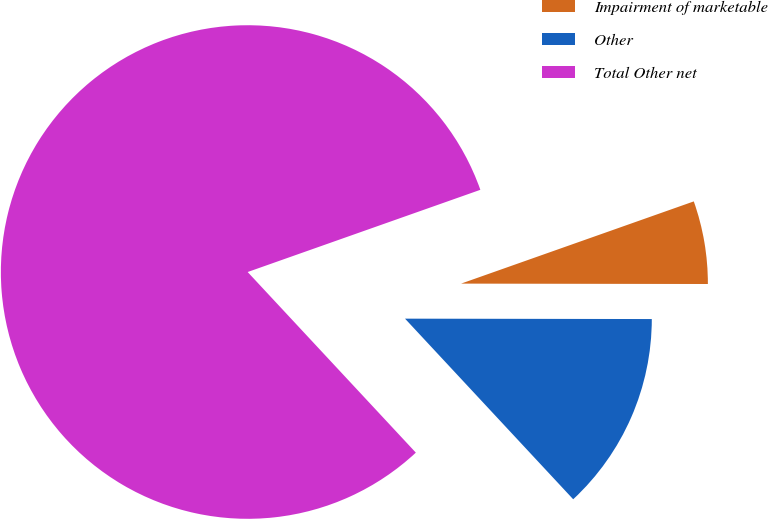Convert chart. <chart><loc_0><loc_0><loc_500><loc_500><pie_chart><fcel>Impairment of marketable<fcel>Other<fcel>Total Other net<nl><fcel>5.43%<fcel>13.04%<fcel>81.52%<nl></chart> 